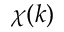<formula> <loc_0><loc_0><loc_500><loc_500>\chi ( k )</formula> 